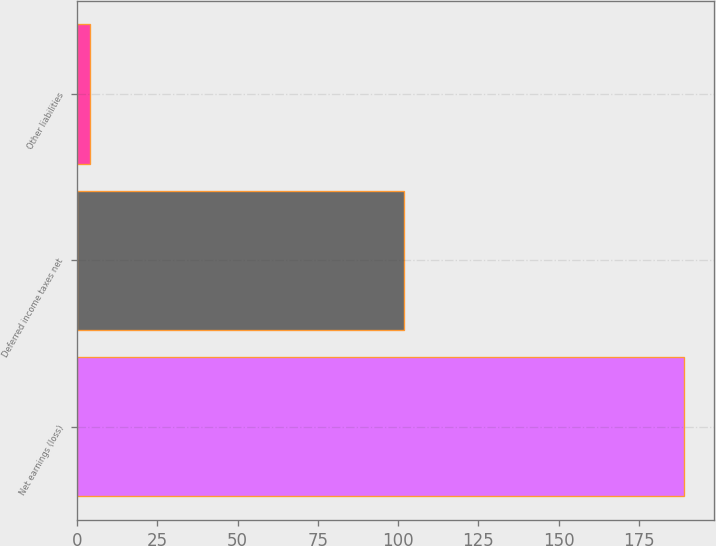Convert chart. <chart><loc_0><loc_0><loc_500><loc_500><bar_chart><fcel>Net earnings (loss)<fcel>Deferred income taxes net<fcel>Other liabilities<nl><fcel>189<fcel>102<fcel>4<nl></chart> 